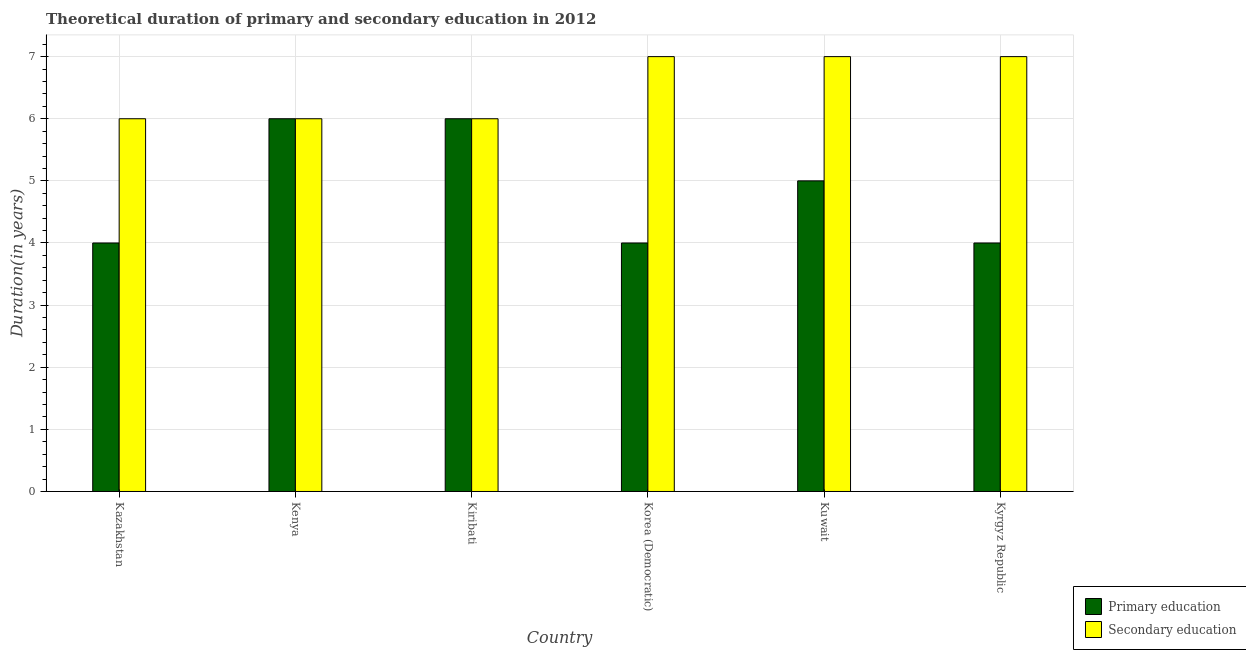Are the number of bars per tick equal to the number of legend labels?
Your answer should be compact. Yes. Are the number of bars on each tick of the X-axis equal?
Give a very brief answer. Yes. How many bars are there on the 3rd tick from the right?
Provide a short and direct response. 2. What is the label of the 6th group of bars from the left?
Your response must be concise. Kyrgyz Republic. In how many cases, is the number of bars for a given country not equal to the number of legend labels?
Ensure brevity in your answer.  0. What is the duration of primary education in Kiribati?
Make the answer very short. 6. Across all countries, what is the maximum duration of secondary education?
Provide a short and direct response. 7. Across all countries, what is the minimum duration of primary education?
Your response must be concise. 4. In which country was the duration of primary education maximum?
Your answer should be compact. Kenya. In which country was the duration of secondary education minimum?
Your answer should be very brief. Kazakhstan. What is the total duration of primary education in the graph?
Provide a short and direct response. 29. What is the difference between the duration of secondary education in Kazakhstan and that in Kenya?
Your answer should be compact. 0. What is the difference between the duration of primary education in Kazakhstan and the duration of secondary education in Kyrgyz Republic?
Provide a short and direct response. -3. What is the difference between the duration of primary education and duration of secondary education in Kuwait?
Your response must be concise. -2. What is the ratio of the duration of secondary education in Kenya to that in Kyrgyz Republic?
Offer a very short reply. 0.86. Is the difference between the duration of secondary education in Kazakhstan and Kiribati greater than the difference between the duration of primary education in Kazakhstan and Kiribati?
Your answer should be very brief. Yes. What is the difference between the highest and the lowest duration of secondary education?
Your answer should be compact. 1. In how many countries, is the duration of secondary education greater than the average duration of secondary education taken over all countries?
Give a very brief answer. 3. What does the 1st bar from the left in Kenya represents?
Your answer should be compact. Primary education. How many countries are there in the graph?
Give a very brief answer. 6. Are the values on the major ticks of Y-axis written in scientific E-notation?
Offer a very short reply. No. Does the graph contain any zero values?
Keep it short and to the point. No. How are the legend labels stacked?
Your response must be concise. Vertical. What is the title of the graph?
Offer a very short reply. Theoretical duration of primary and secondary education in 2012. What is the label or title of the Y-axis?
Provide a short and direct response. Duration(in years). What is the Duration(in years) of Secondary education in Kazakhstan?
Your answer should be compact. 6. What is the Duration(in years) in Primary education in Kenya?
Provide a succinct answer. 6. What is the Duration(in years) in Primary education in Korea (Democratic)?
Your answer should be very brief. 4. What is the Duration(in years) of Secondary education in Korea (Democratic)?
Your response must be concise. 7. What is the Duration(in years) in Secondary education in Kuwait?
Offer a terse response. 7. What is the Duration(in years) in Primary education in Kyrgyz Republic?
Give a very brief answer. 4. What is the Duration(in years) in Secondary education in Kyrgyz Republic?
Your response must be concise. 7. Across all countries, what is the maximum Duration(in years) of Secondary education?
Your answer should be very brief. 7. Across all countries, what is the minimum Duration(in years) of Primary education?
Offer a terse response. 4. What is the total Duration(in years) in Primary education in the graph?
Ensure brevity in your answer.  29. What is the total Duration(in years) of Secondary education in the graph?
Your answer should be compact. 39. What is the difference between the Duration(in years) of Primary education in Kazakhstan and that in Kenya?
Provide a succinct answer. -2. What is the difference between the Duration(in years) of Primary education in Kazakhstan and that in Kiribati?
Offer a very short reply. -2. What is the difference between the Duration(in years) in Primary education in Kazakhstan and that in Korea (Democratic)?
Provide a short and direct response. 0. What is the difference between the Duration(in years) in Secondary education in Kazakhstan and that in Kuwait?
Offer a terse response. -1. What is the difference between the Duration(in years) of Primary education in Kazakhstan and that in Kyrgyz Republic?
Make the answer very short. 0. What is the difference between the Duration(in years) of Secondary education in Kenya and that in Kiribati?
Offer a very short reply. 0. What is the difference between the Duration(in years) in Secondary education in Kenya and that in Korea (Democratic)?
Ensure brevity in your answer.  -1. What is the difference between the Duration(in years) of Primary education in Kenya and that in Kuwait?
Offer a terse response. 1. What is the difference between the Duration(in years) in Secondary education in Kenya and that in Kuwait?
Offer a very short reply. -1. What is the difference between the Duration(in years) in Primary education in Kenya and that in Kyrgyz Republic?
Offer a terse response. 2. What is the difference between the Duration(in years) of Secondary education in Kiribati and that in Kuwait?
Provide a succinct answer. -1. What is the difference between the Duration(in years) of Primary education in Kiribati and that in Kyrgyz Republic?
Your answer should be compact. 2. What is the difference between the Duration(in years) in Secondary education in Korea (Democratic) and that in Kuwait?
Offer a terse response. 0. What is the difference between the Duration(in years) of Primary education in Kazakhstan and the Duration(in years) of Secondary education in Kuwait?
Ensure brevity in your answer.  -3. What is the difference between the Duration(in years) in Primary education in Kazakhstan and the Duration(in years) in Secondary education in Kyrgyz Republic?
Make the answer very short. -3. What is the difference between the Duration(in years) of Primary education in Kenya and the Duration(in years) of Secondary education in Kyrgyz Republic?
Offer a very short reply. -1. What is the difference between the Duration(in years) of Primary education in Kiribati and the Duration(in years) of Secondary education in Korea (Democratic)?
Provide a succinct answer. -1. What is the difference between the Duration(in years) of Primary education in Kiribati and the Duration(in years) of Secondary education in Kuwait?
Offer a terse response. -1. What is the difference between the Duration(in years) in Primary education in Kiribati and the Duration(in years) in Secondary education in Kyrgyz Republic?
Your answer should be very brief. -1. What is the difference between the Duration(in years) in Primary education in Korea (Democratic) and the Duration(in years) in Secondary education in Kuwait?
Keep it short and to the point. -3. What is the average Duration(in years) of Primary education per country?
Give a very brief answer. 4.83. What is the difference between the Duration(in years) in Primary education and Duration(in years) in Secondary education in Kazakhstan?
Your response must be concise. -2. What is the difference between the Duration(in years) in Primary education and Duration(in years) in Secondary education in Kiribati?
Provide a short and direct response. 0. What is the difference between the Duration(in years) in Primary education and Duration(in years) in Secondary education in Korea (Democratic)?
Offer a very short reply. -3. What is the difference between the Duration(in years) of Primary education and Duration(in years) of Secondary education in Kuwait?
Make the answer very short. -2. What is the difference between the Duration(in years) in Primary education and Duration(in years) in Secondary education in Kyrgyz Republic?
Provide a succinct answer. -3. What is the ratio of the Duration(in years) in Primary education in Kazakhstan to that in Kenya?
Provide a succinct answer. 0.67. What is the ratio of the Duration(in years) of Primary education in Kazakhstan to that in Kuwait?
Offer a very short reply. 0.8. What is the ratio of the Duration(in years) in Primary education in Kazakhstan to that in Kyrgyz Republic?
Provide a succinct answer. 1. What is the ratio of the Duration(in years) in Secondary education in Kazakhstan to that in Kyrgyz Republic?
Your answer should be very brief. 0.86. What is the ratio of the Duration(in years) of Primary education in Kenya to that in Korea (Democratic)?
Make the answer very short. 1.5. What is the ratio of the Duration(in years) in Secondary education in Kenya to that in Korea (Democratic)?
Your answer should be compact. 0.86. What is the ratio of the Duration(in years) of Secondary education in Kenya to that in Kuwait?
Give a very brief answer. 0.86. What is the ratio of the Duration(in years) in Primary education in Kenya to that in Kyrgyz Republic?
Keep it short and to the point. 1.5. What is the ratio of the Duration(in years) in Secondary education in Kenya to that in Kyrgyz Republic?
Offer a terse response. 0.86. What is the ratio of the Duration(in years) in Primary education in Korea (Democratic) to that in Kuwait?
Make the answer very short. 0.8. What is the ratio of the Duration(in years) of Secondary education in Korea (Democratic) to that in Kuwait?
Make the answer very short. 1. What is the ratio of the Duration(in years) in Primary education in Korea (Democratic) to that in Kyrgyz Republic?
Your answer should be compact. 1. What is the ratio of the Duration(in years) in Primary education in Kuwait to that in Kyrgyz Republic?
Provide a short and direct response. 1.25. What is the ratio of the Duration(in years) of Secondary education in Kuwait to that in Kyrgyz Republic?
Provide a succinct answer. 1. What is the difference between the highest and the second highest Duration(in years) of Primary education?
Your response must be concise. 0. What is the difference between the highest and the second highest Duration(in years) in Secondary education?
Your answer should be very brief. 0. What is the difference between the highest and the lowest Duration(in years) in Primary education?
Your response must be concise. 2. 